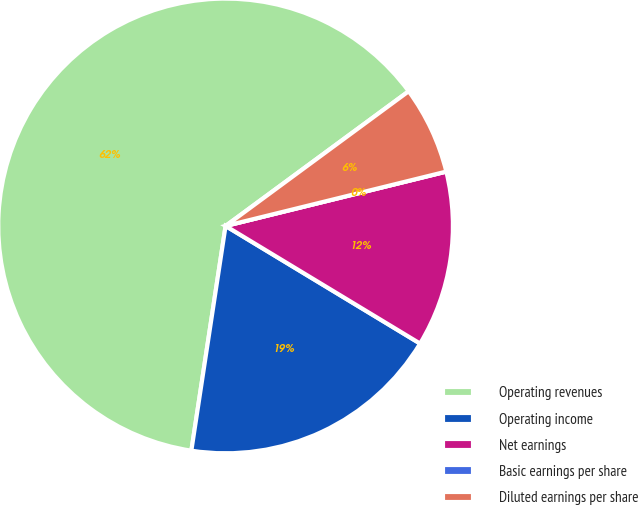<chart> <loc_0><loc_0><loc_500><loc_500><pie_chart><fcel>Operating revenues<fcel>Operating income<fcel>Net earnings<fcel>Basic earnings per share<fcel>Diluted earnings per share<nl><fcel>62.5%<fcel>18.75%<fcel>12.5%<fcel>0.0%<fcel>6.25%<nl></chart> 